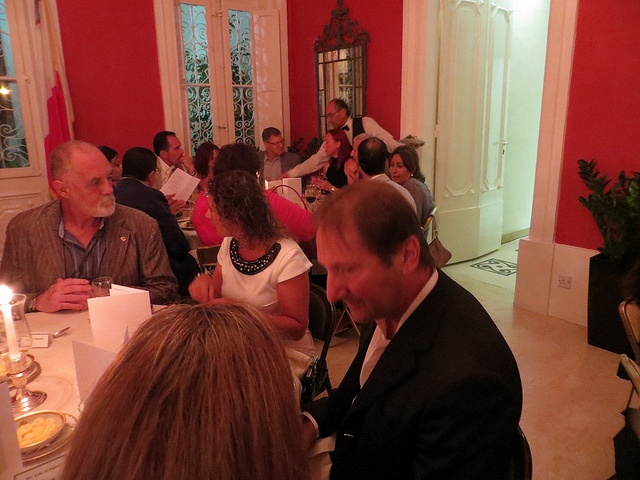Describe the objects in this image and their specific colors. I can see people in lightblue, black, maroon, and brown tones, people in lightblue, maroon, and brown tones, people in lightblue, maroon, brown, and black tones, dining table in lightblue, salmon, and brown tones, and people in lightblue, black, maroon, brown, and salmon tones in this image. 